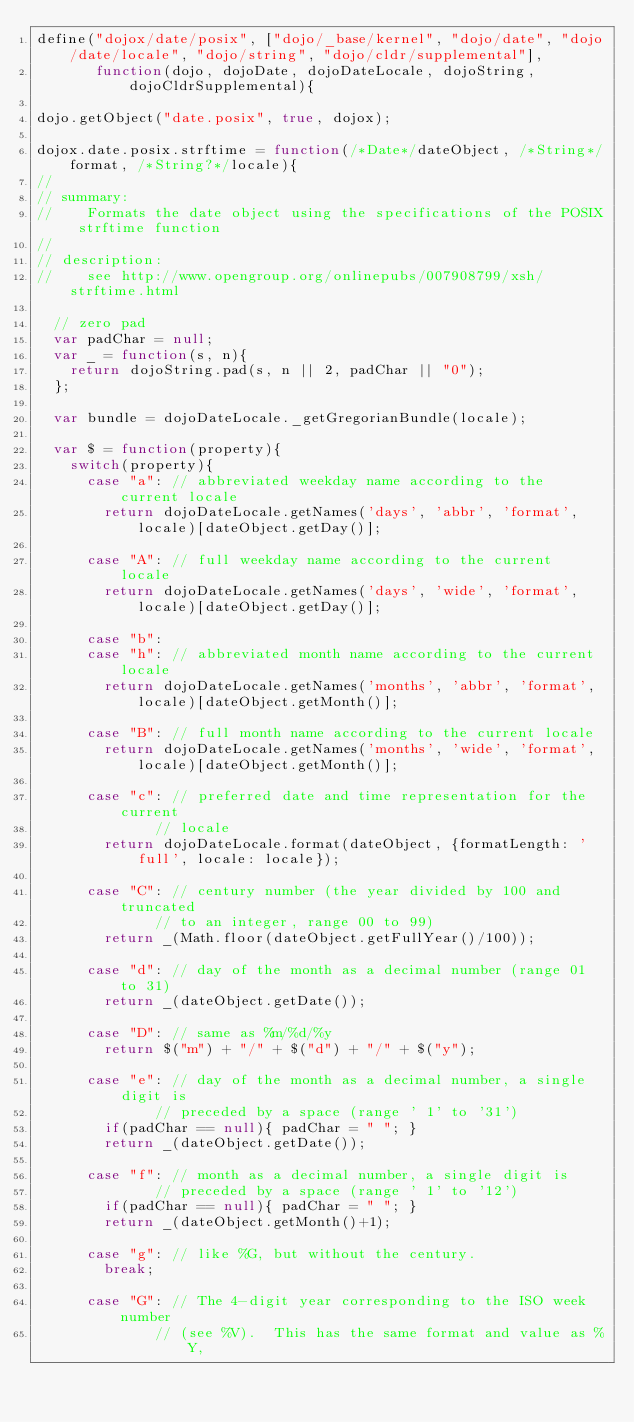Convert code to text. <code><loc_0><loc_0><loc_500><loc_500><_JavaScript_>define("dojox/date/posix", ["dojo/_base/kernel", "dojo/date", "dojo/date/locale", "dojo/string", "dojo/cldr/supplemental"],
       function(dojo, dojoDate, dojoDateLocale, dojoString, dojoCldrSupplemental){

dojo.getObject("date.posix", true, dojox);

dojox.date.posix.strftime = function(/*Date*/dateObject, /*String*/format, /*String?*/locale){
//
// summary:
//		Formats the date object using the specifications of the POSIX strftime function
//
// description:
//		see http://www.opengroup.org/onlinepubs/007908799/xsh/strftime.html

	// zero pad
	var padChar = null;
	var _ = function(s, n){
		return dojoString.pad(s, n || 2, padChar || "0");
	};

	var bundle = dojoDateLocale._getGregorianBundle(locale);

	var $ = function(property){
		switch(property){
			case "a": // abbreviated weekday name according to the current locale
				return dojoDateLocale.getNames('days', 'abbr', 'format', locale)[dateObject.getDay()];

			case "A": // full weekday name according to the current locale
				return dojoDateLocale.getNames('days', 'wide', 'format', locale)[dateObject.getDay()];

			case "b":
			case "h": // abbreviated month name according to the current locale
				return dojoDateLocale.getNames('months', 'abbr', 'format', locale)[dateObject.getMonth()];
				
			case "B": // full month name according to the current locale
				return dojoDateLocale.getNames('months', 'wide', 'format', locale)[dateObject.getMonth()];
				
			case "c": // preferred date and time representation for the current
				      // locale
				return dojoDateLocale.format(dateObject, {formatLength: 'full', locale: locale});

			case "C": // century number (the year divided by 100 and truncated
				      // to an integer, range 00 to 99)
				return _(Math.floor(dateObject.getFullYear()/100));
				
			case "d": // day of the month as a decimal number (range 01 to 31)
				return _(dateObject.getDate());
				
			case "D": // same as %m/%d/%y
				return $("m") + "/" + $("d") + "/" + $("y");
					
			case "e": // day of the month as a decimal number, a single digit is
				      // preceded by a space (range ' 1' to '31')
				if(padChar == null){ padChar = " "; }
				return _(dateObject.getDate());
			
			case "f": // month as a decimal number, a single digit is
							// preceded by a space (range ' 1' to '12')
				if(padChar == null){ padChar = " "; }
				return _(dateObject.getMonth()+1);
			
			case "g": // like %G, but without the century.
				break;
			
			case "G": // The 4-digit year corresponding to the ISO week number
				      // (see %V).  This has the same format and value as %Y,</code> 